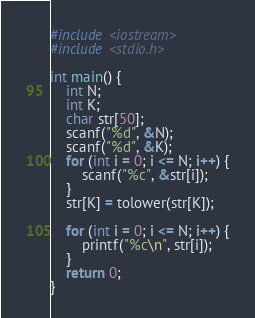Convert code to text. <code><loc_0><loc_0><loc_500><loc_500><_C++_>
#include <iostream>
#include <stdio.h>

int main() {
	int N;
	int K;
	char str[50];
	scanf("%d", &N);
	scanf("%d", &K);
	for (int i = 0; i <= N; i++) {
		scanf("%c", &str[i]);
	}
	str[K] = tolower(str[K]);

	for (int i = 0; i <= N; i++) {
		printf("%c\n", str[i]);
	}
	return 0;
}
</code> 